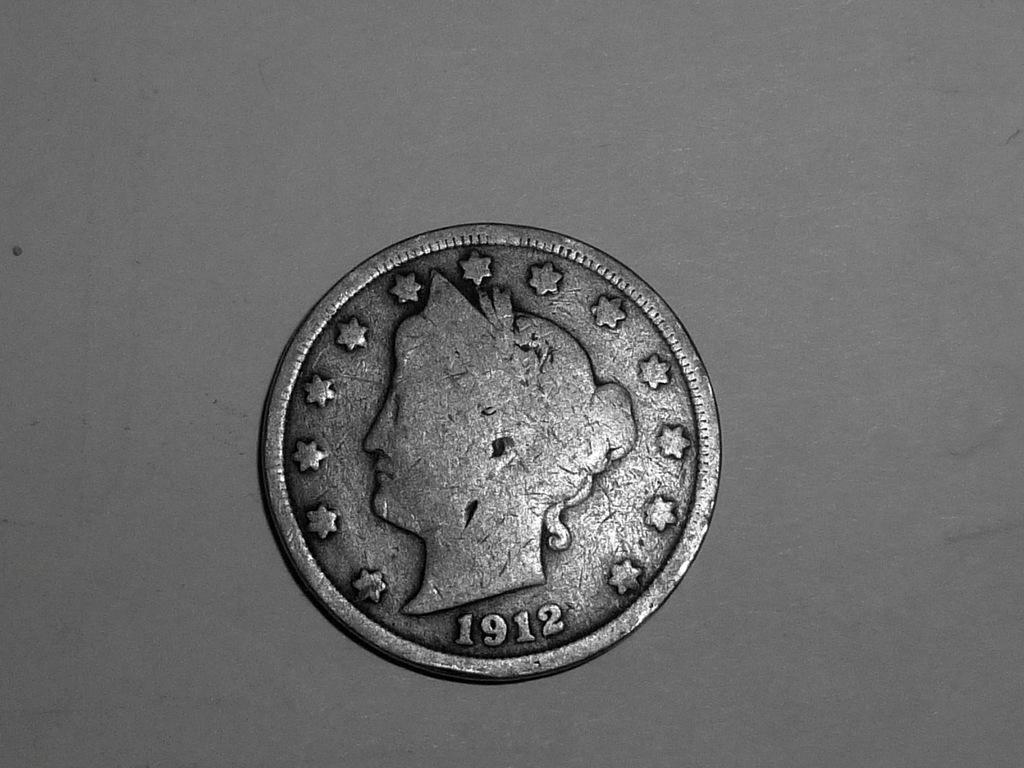<image>
Write a terse but informative summary of the picture. An older silver coin was minted in 1912. 